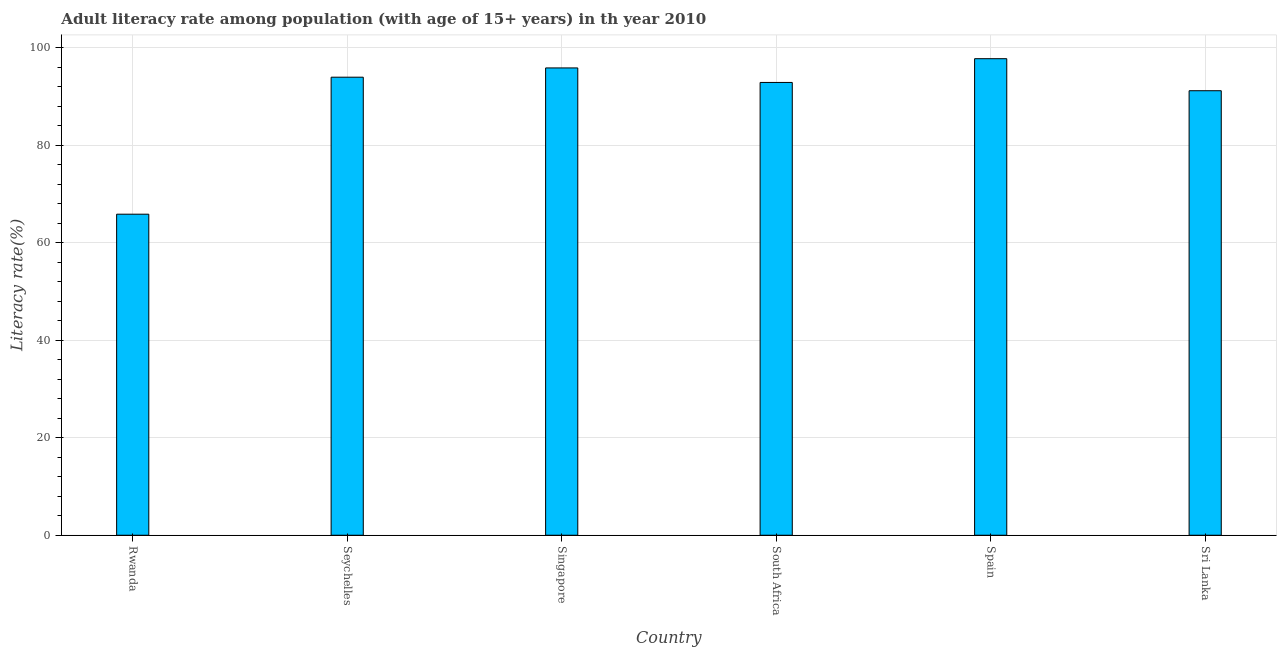Does the graph contain any zero values?
Ensure brevity in your answer.  No. What is the title of the graph?
Provide a succinct answer. Adult literacy rate among population (with age of 15+ years) in th year 2010. What is the label or title of the X-axis?
Your response must be concise. Country. What is the label or title of the Y-axis?
Offer a very short reply. Literacy rate(%). What is the adult literacy rate in Sri Lanka?
Offer a terse response. 91.18. Across all countries, what is the maximum adult literacy rate?
Keep it short and to the point. 97.75. Across all countries, what is the minimum adult literacy rate?
Keep it short and to the point. 65.85. In which country was the adult literacy rate minimum?
Make the answer very short. Rwanda. What is the sum of the adult literacy rate?
Offer a terse response. 537.47. What is the difference between the adult literacy rate in Seychelles and South Africa?
Offer a terse response. 1.08. What is the average adult literacy rate per country?
Give a very brief answer. 89.58. What is the median adult literacy rate?
Ensure brevity in your answer.  93.42. In how many countries, is the adult literacy rate greater than 40 %?
Keep it short and to the point. 6. What is the ratio of the adult literacy rate in Rwanda to that in Seychelles?
Offer a terse response. 0.7. Is the difference between the adult literacy rate in Rwanda and Singapore greater than the difference between any two countries?
Give a very brief answer. No. What is the difference between the highest and the second highest adult literacy rate?
Your answer should be very brief. 1.89. What is the difference between the highest and the lowest adult literacy rate?
Offer a very short reply. 31.9. In how many countries, is the adult literacy rate greater than the average adult literacy rate taken over all countries?
Offer a terse response. 5. How many bars are there?
Offer a very short reply. 6. What is the Literacy rate(%) of Rwanda?
Your response must be concise. 65.85. What is the Literacy rate(%) of Seychelles?
Make the answer very short. 93.95. What is the Literacy rate(%) in Singapore?
Offer a very short reply. 95.86. What is the Literacy rate(%) in South Africa?
Give a very brief answer. 92.88. What is the Literacy rate(%) in Spain?
Offer a very short reply. 97.75. What is the Literacy rate(%) in Sri Lanka?
Keep it short and to the point. 91.18. What is the difference between the Literacy rate(%) in Rwanda and Seychelles?
Make the answer very short. -28.1. What is the difference between the Literacy rate(%) in Rwanda and Singapore?
Give a very brief answer. -30.01. What is the difference between the Literacy rate(%) in Rwanda and South Africa?
Give a very brief answer. -27.03. What is the difference between the Literacy rate(%) in Rwanda and Spain?
Ensure brevity in your answer.  -31.9. What is the difference between the Literacy rate(%) in Rwanda and Sri Lanka?
Offer a very short reply. -25.33. What is the difference between the Literacy rate(%) in Seychelles and Singapore?
Offer a very short reply. -1.9. What is the difference between the Literacy rate(%) in Seychelles and South Africa?
Keep it short and to the point. 1.08. What is the difference between the Literacy rate(%) in Seychelles and Spain?
Offer a very short reply. -3.79. What is the difference between the Literacy rate(%) in Seychelles and Sri Lanka?
Offer a very short reply. 2.77. What is the difference between the Literacy rate(%) in Singapore and South Africa?
Your answer should be compact. 2.98. What is the difference between the Literacy rate(%) in Singapore and Spain?
Your answer should be compact. -1.89. What is the difference between the Literacy rate(%) in Singapore and Sri Lanka?
Offer a very short reply. 4.68. What is the difference between the Literacy rate(%) in South Africa and Spain?
Make the answer very short. -4.87. What is the difference between the Literacy rate(%) in South Africa and Sri Lanka?
Provide a short and direct response. 1.7. What is the difference between the Literacy rate(%) in Spain and Sri Lanka?
Offer a very short reply. 6.57. What is the ratio of the Literacy rate(%) in Rwanda to that in Seychelles?
Keep it short and to the point. 0.7. What is the ratio of the Literacy rate(%) in Rwanda to that in Singapore?
Make the answer very short. 0.69. What is the ratio of the Literacy rate(%) in Rwanda to that in South Africa?
Offer a very short reply. 0.71. What is the ratio of the Literacy rate(%) in Rwanda to that in Spain?
Your response must be concise. 0.67. What is the ratio of the Literacy rate(%) in Rwanda to that in Sri Lanka?
Your answer should be very brief. 0.72. What is the ratio of the Literacy rate(%) in Seychelles to that in Singapore?
Your answer should be very brief. 0.98. What is the ratio of the Literacy rate(%) in Seychelles to that in South Africa?
Give a very brief answer. 1.01. What is the ratio of the Literacy rate(%) in Seychelles to that in Spain?
Keep it short and to the point. 0.96. What is the ratio of the Literacy rate(%) in Seychelles to that in Sri Lanka?
Your answer should be very brief. 1.03. What is the ratio of the Literacy rate(%) in Singapore to that in South Africa?
Provide a short and direct response. 1.03. What is the ratio of the Literacy rate(%) in Singapore to that in Spain?
Provide a short and direct response. 0.98. What is the ratio of the Literacy rate(%) in Singapore to that in Sri Lanka?
Make the answer very short. 1.05. What is the ratio of the Literacy rate(%) in South Africa to that in Sri Lanka?
Provide a short and direct response. 1.02. What is the ratio of the Literacy rate(%) in Spain to that in Sri Lanka?
Your answer should be very brief. 1.07. 